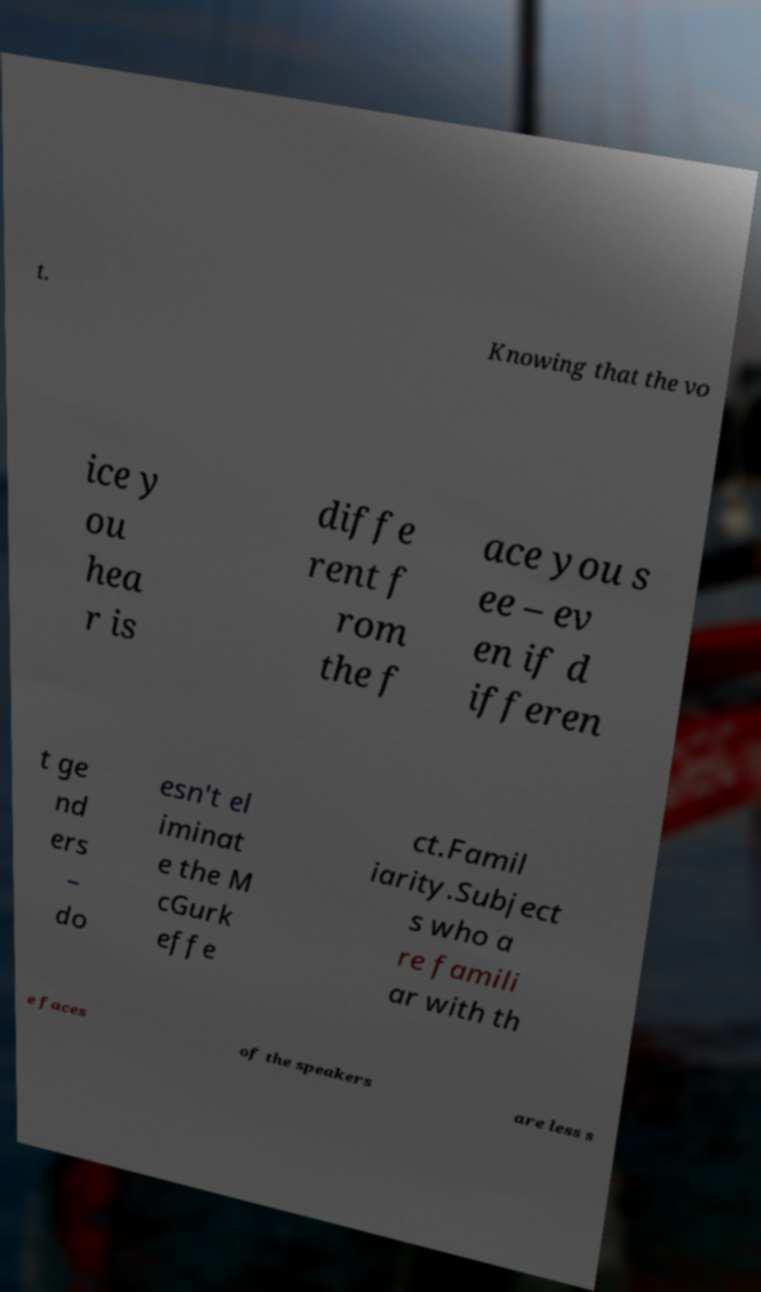Please identify and transcribe the text found in this image. t. Knowing that the vo ice y ou hea r is diffe rent f rom the f ace you s ee – ev en if d ifferen t ge nd ers – do esn't el iminat e the M cGurk effe ct.Famil iarity.Subject s who a re famili ar with th e faces of the speakers are less s 